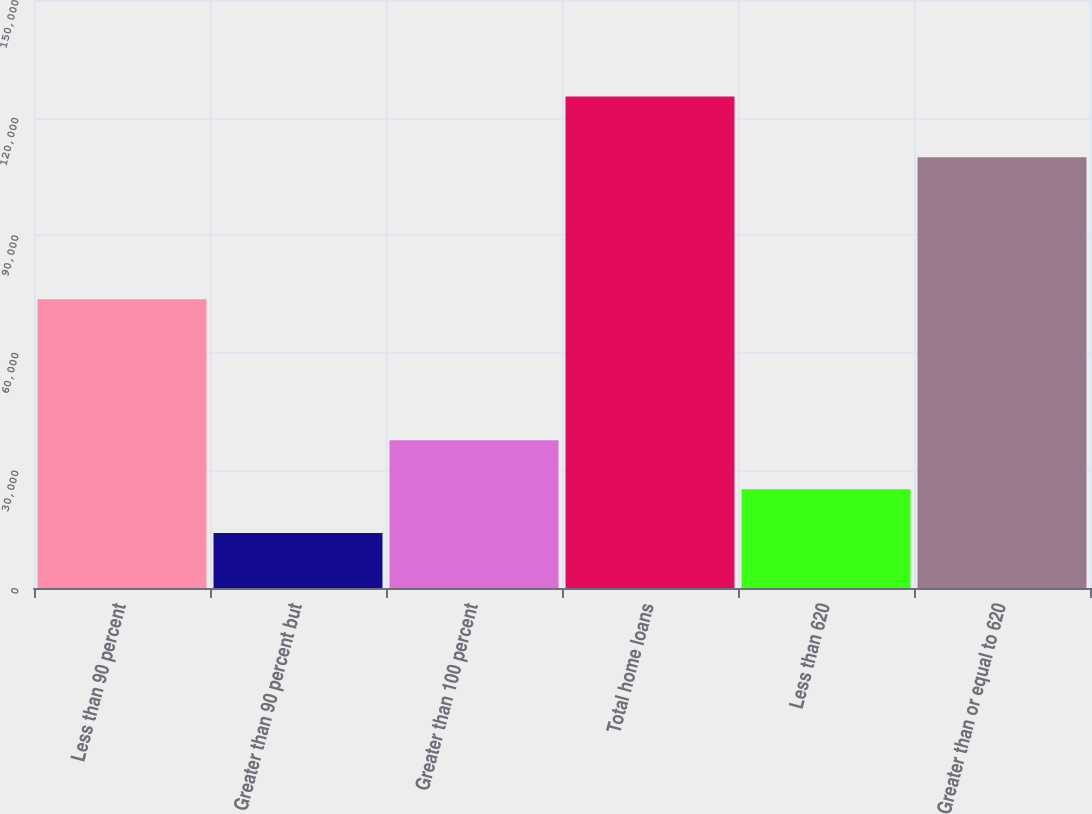<chart> <loc_0><loc_0><loc_500><loc_500><bar_chart><fcel>Less than 90 percent<fcel>Greater than 90 percent but<fcel>Greater than 100 percent<fcel>Total home loans<fcel>Less than 620<fcel>Greater than or equal to 620<nl><fcel>73680<fcel>14038<fcel>37673<fcel>125391<fcel>25173.3<fcel>109897<nl></chart> 